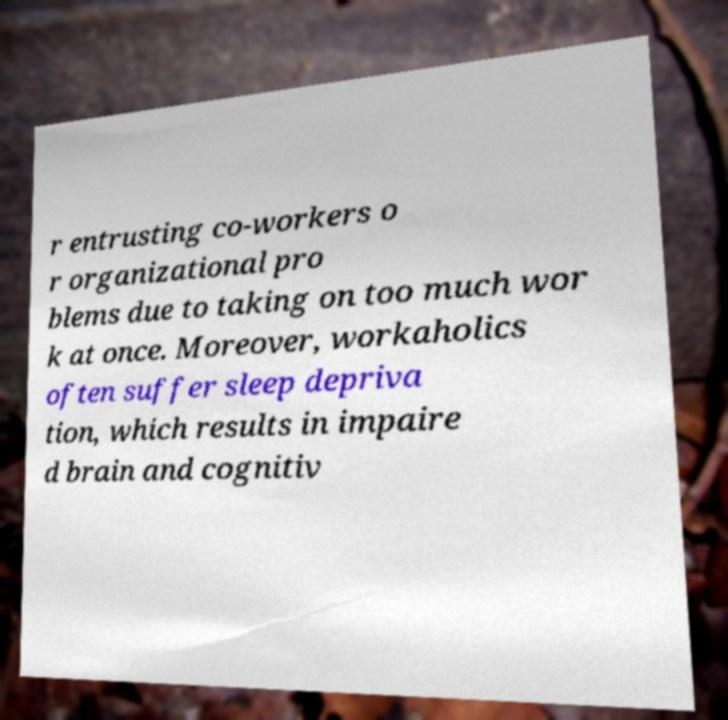Could you assist in decoding the text presented in this image and type it out clearly? r entrusting co-workers o r organizational pro blems due to taking on too much wor k at once. Moreover, workaholics often suffer sleep depriva tion, which results in impaire d brain and cognitiv 